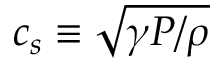Convert formula to latex. <formula><loc_0><loc_0><loc_500><loc_500>c _ { s } \equiv \sqrt { \gamma P / \rho }</formula> 